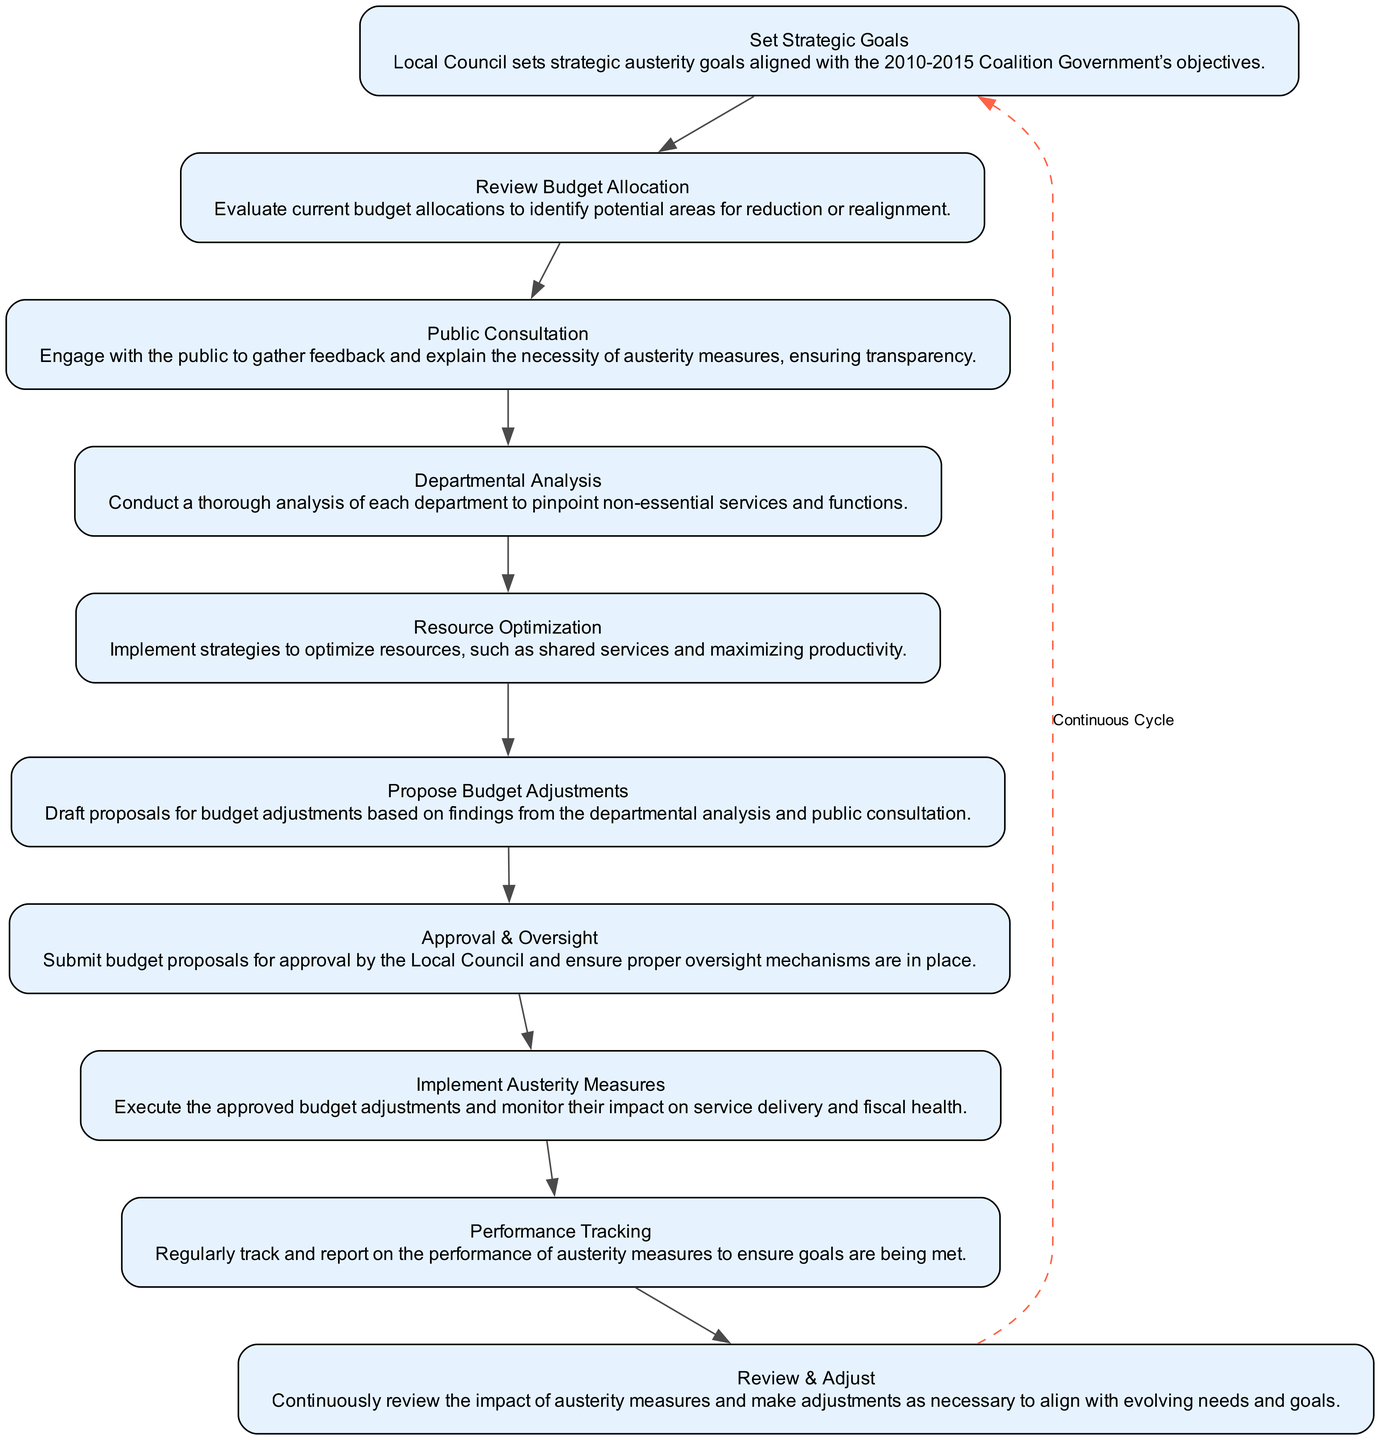What is the first step in the flow chart? The flow chart begins with "Set Strategic Goals", which is the first node in the sequence.
Answer: Set Strategic Goals How many total steps are represented in the flow chart? The flow chart has ten distinct nodes that represent different steps in the implementation process.
Answer: Ten Which step directly follows "Public Consultation"? After "Public Consultation", the next step indicated in the flow chart is "Departmental Analysis".
Answer: Departmental Analysis What is the relationship between "Implement Austerity Measures" and "Performance Tracking"? "Implement Austerity Measures" is followed by "Performance Tracking", indicating a sequential relationship where monitoring occurs after implementation.
Answer: Sequential relationship Which step provides feedback to the public? The step entitled "Public Consultation" specifically engages with the public for feedback on austerity measures.
Answer: Public Consultation What do "Resource Optimization" and "Departmental Analysis" have in common? Both "Resource Optimization" and "Departmental Analysis" focus on assessing and improving the efficiency of local council operations in the austerity process.
Answer: Improvement of efficiency What does the dashed edge in the flow chart represent? The dashed edge from "Review & Adjust" back to "Set Strategic Goals" represents a continuous cycle of revisiting the goals after evaluations.
Answer: Continuous Cycle Which steps directly involve budget-related activities? The steps that involve budget-related activities are "Review Budget Allocation", "Propose Budget Adjustments", and "Approval & Oversight".
Answer: Three steps What indicates that there might be adjustments after austerity measures are implemented? The step "Review & Adjust" signifies that there will be ongoing evaluation and potential adjustments to the austerity measures once they are implemented.
Answer: Review & Adjust 